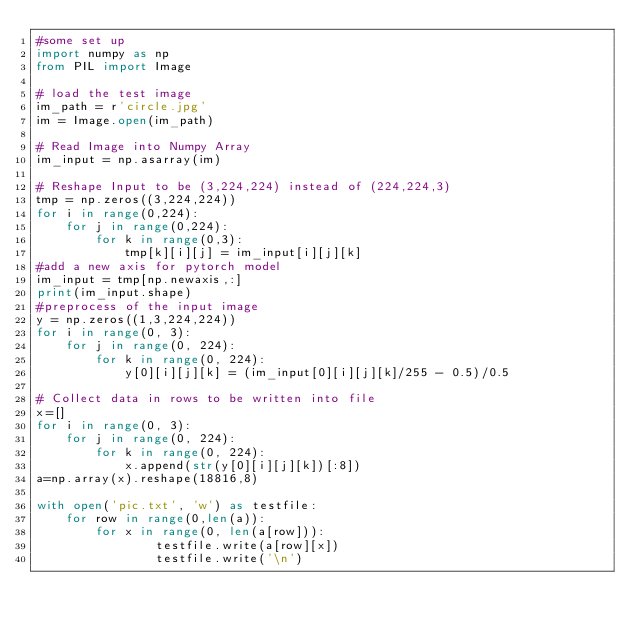Convert code to text. <code><loc_0><loc_0><loc_500><loc_500><_Python_>#some set up
import numpy as np
from PIL import Image

# load the test image
im_path = r'circle.jpg'
im = Image.open(im_path)

# Read Image into Numpy Array
im_input = np.asarray(im)

# Reshape Input to be (3,224,224) instead of (224,224,3)
tmp = np.zeros((3,224,224))
for i in range(0,224):
    for j in range(0,224):
        for k in range(0,3):
            tmp[k][i][j] = im_input[i][j][k]
#add a new axis for pytorch model
im_input = tmp[np.newaxis,:]
print(im_input.shape)
#preprocess of the input image
y = np.zeros((1,3,224,224))
for i in range(0, 3):
    for j in range(0, 224):
        for k in range(0, 224):
            y[0][i][j][k] = (im_input[0][i][j][k]/255 - 0.5)/0.5

# Collect data in rows to be written into file
x=[]
for i in range(0, 3):
    for j in range(0, 224):
        for k in range(0, 224):
            x.append(str(y[0][i][j][k])[:8])
a=np.array(x).reshape(18816,8)

with open('pic.txt', 'w') as testfile:
    for row in range(0,len(a)):
        for x in range(0, len(a[row])):
                testfile.write(a[row][x])
                testfile.write('\n')
</code> 